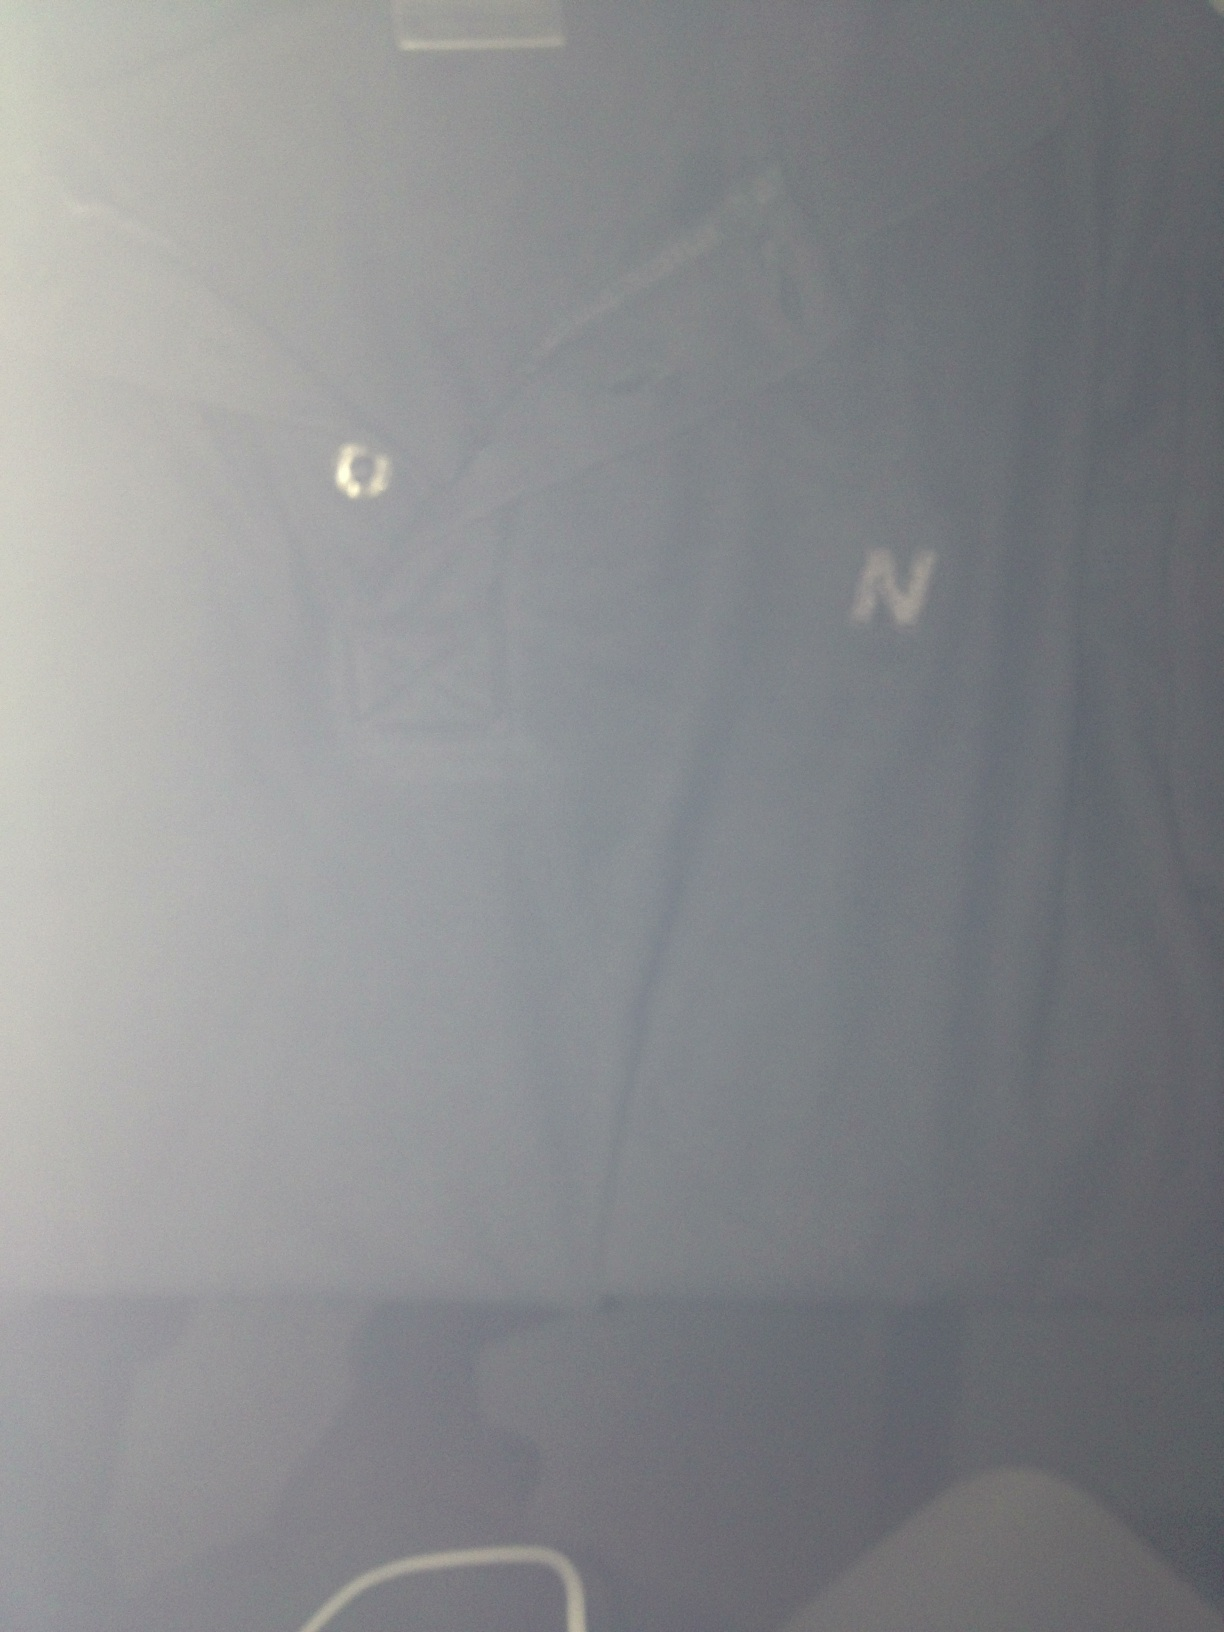Create a story about how this tee shirt became someone's favorite piece of clothing. Once upon a time, there was a young man named Alex who stumbled upon this dark blue tee shirt while on a spontaneous shopping trip. He was instantly drawn to its unique design and comfortable feel. Over time, this tee shirt became his go-to for almost every occasion. He wore it to his first job interview, where he landed his dream job, and it was the sharegpt4v/same tee shirt he wore on his first date with his now fiancée. It became a symbol of his personal growth and memorable milestones, making it his favorite piece of clothing. 